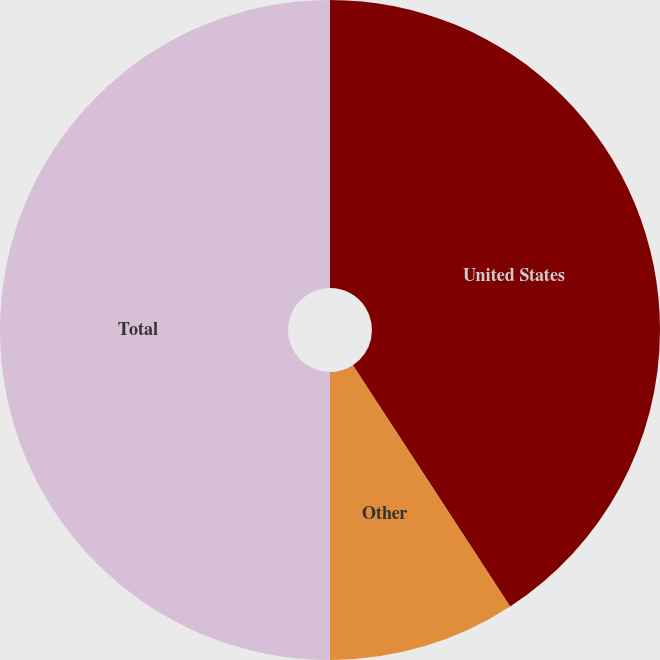Convert chart. <chart><loc_0><loc_0><loc_500><loc_500><pie_chart><fcel>United States<fcel>Other<fcel>Total<nl><fcel>40.81%<fcel>9.19%<fcel>50.0%<nl></chart> 